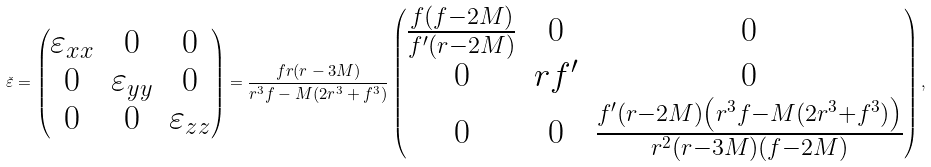<formula> <loc_0><loc_0><loc_500><loc_500>\check { \varepsilon } = \begin{pmatrix} \varepsilon _ { x x } & 0 & 0 \\ 0 & \varepsilon _ { y y } & 0 \\ 0 & 0 & \varepsilon _ { z z } \end{pmatrix} = \frac { f r ( r - 3 M ) } { r ^ { 3 } f - M ( 2 r ^ { 3 } + f ^ { 3 } ) } \begin{pmatrix} \frac { f ( f - 2 M ) } { f ^ { \prime } ( r - 2 M ) } & 0 & 0 \\ 0 & r f ^ { \prime } & 0 \\ 0 & 0 & \frac { f ^ { \prime } ( r - 2 M ) \left ( r ^ { 3 } f - M ( 2 r ^ { 3 } + f ^ { 3 } ) \right ) } { r ^ { 2 } ( r - 3 M ) ( f - 2 M ) } \end{pmatrix} ,</formula> 